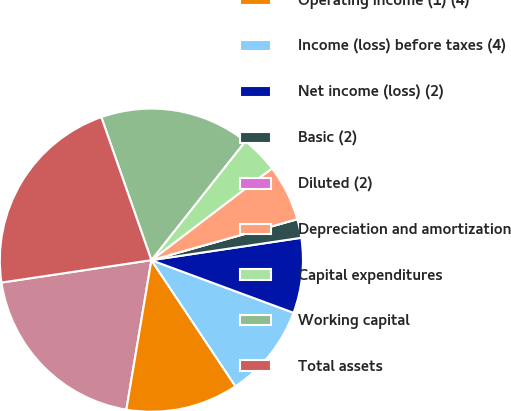Convert chart to OTSL. <chart><loc_0><loc_0><loc_500><loc_500><pie_chart><fcel>Revenues<fcel>Operating income (1) (4)<fcel>Income (loss) before taxes (4)<fcel>Net income (loss) (2)<fcel>Basic (2)<fcel>Diluted (2)<fcel>Depreciation and amortization<fcel>Capital expenditures<fcel>Working capital<fcel>Total assets<nl><fcel>20.0%<fcel>12.0%<fcel>10.0%<fcel>8.0%<fcel>2.0%<fcel>0.0%<fcel>6.0%<fcel>4.0%<fcel>16.0%<fcel>22.0%<nl></chart> 